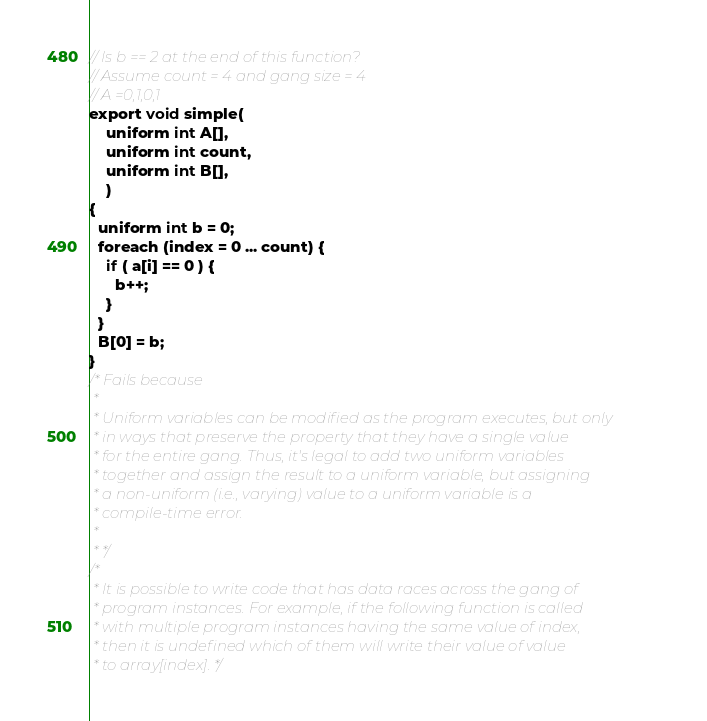Convert code to text. <code><loc_0><loc_0><loc_500><loc_500><_C_>// Is b == 2 at the end of this function?
// Assume count = 4 and gang size = 4
// A =0,1,0,1
export void simple(
    uniform int A[], 
    uniform int count,
    uniform int B[], 
    ) 
{
  uniform int b = 0;
  foreach (index = 0 ... count) {
    if ( a[i] == 0 ) { 
      b++;
    }
  }
  B[0] = b;
}
/* Fails because
 *
 * Uniform variables can be modified as the program executes, but only
 * in ways that preserve the property that they have a single value
 * for the entire gang. Thus, it's legal to add two uniform variables
 * together and assign the result to a uniform variable, but assigning
 * a non-uniform (i.e., varying) value to a uniform variable is a
 * compile-time error.
 *
 * */
/*
 * It is possible to write code that has data races across the gang of
 * program instances. For example, if the following function is called
 * with multiple program instances having the same value of index,
 * then it is undefined which of them will write their value of value
 * to array[index]. */
</code> 